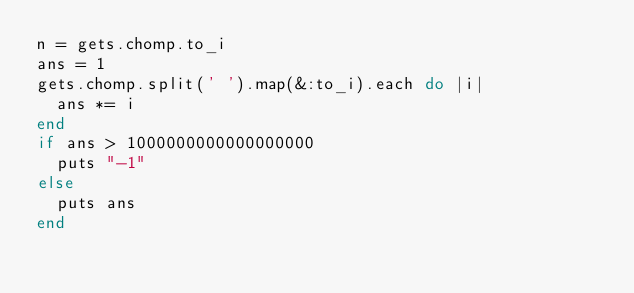Convert code to text. <code><loc_0><loc_0><loc_500><loc_500><_Ruby_>n = gets.chomp.to_i
ans = 1
gets.chomp.split(' ').map(&:to_i).each do |i|
  ans *= i
end
if ans > 1000000000000000000
  puts "-1"
else
  puts ans
end
</code> 